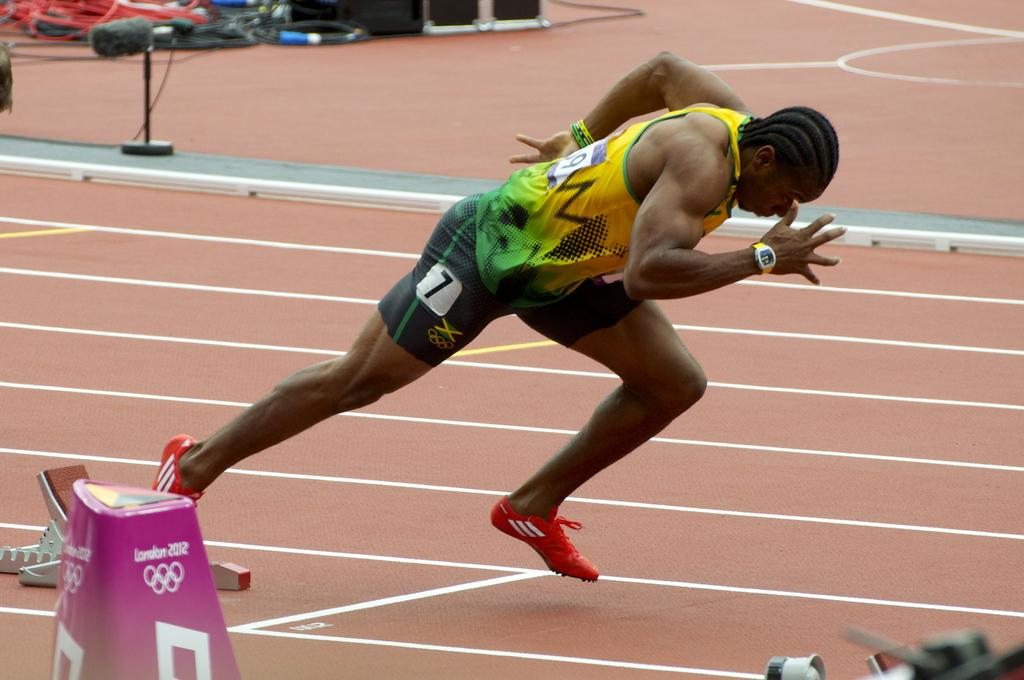What is the person in the image doing? There is a person running in the image. What can be seen in the background of the image? There are cables and speakers in the backdrop of the image. Where does the image take place? The image takes place in a playground. What type of shoe is the porter wearing in the image? There is no porter present in the image, and therefore no shoes to describe. 